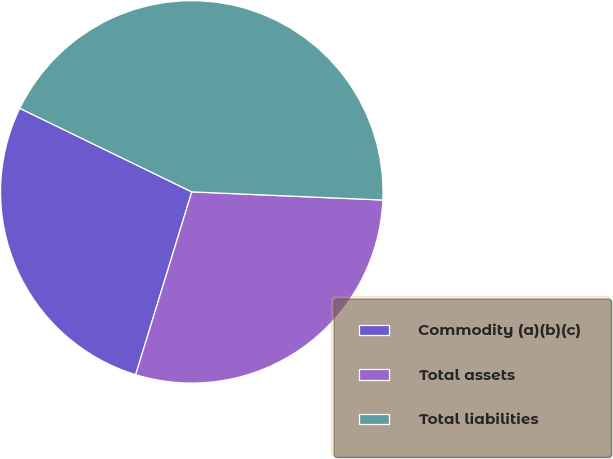<chart> <loc_0><loc_0><loc_500><loc_500><pie_chart><fcel>Commodity (a)(b)(c)<fcel>Total assets<fcel>Total liabilities<nl><fcel>27.46%<fcel>29.06%<fcel>43.48%<nl></chart> 